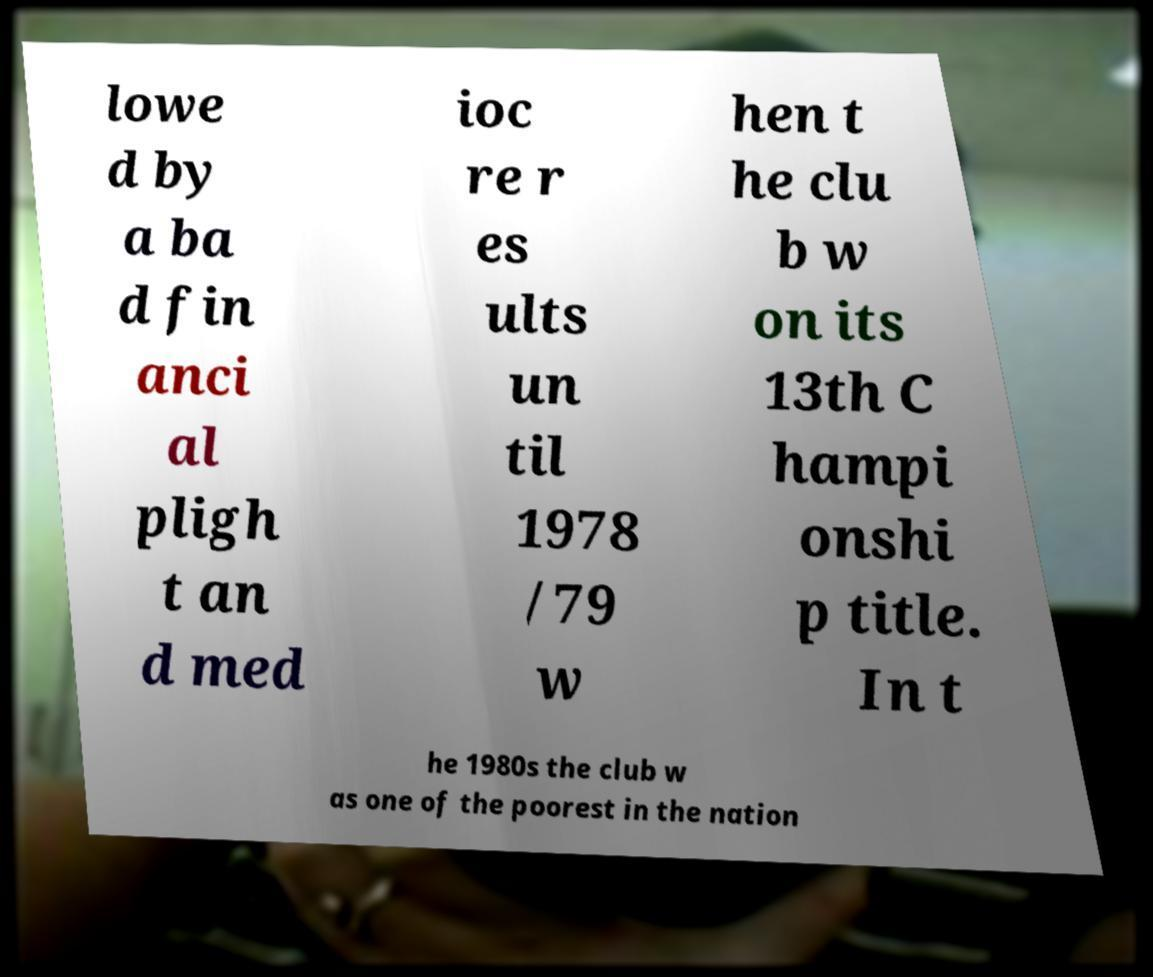Could you assist in decoding the text presented in this image and type it out clearly? lowe d by a ba d fin anci al pligh t an d med ioc re r es ults un til 1978 /79 w hen t he clu b w on its 13th C hampi onshi p title. In t he 1980s the club w as one of the poorest in the nation 